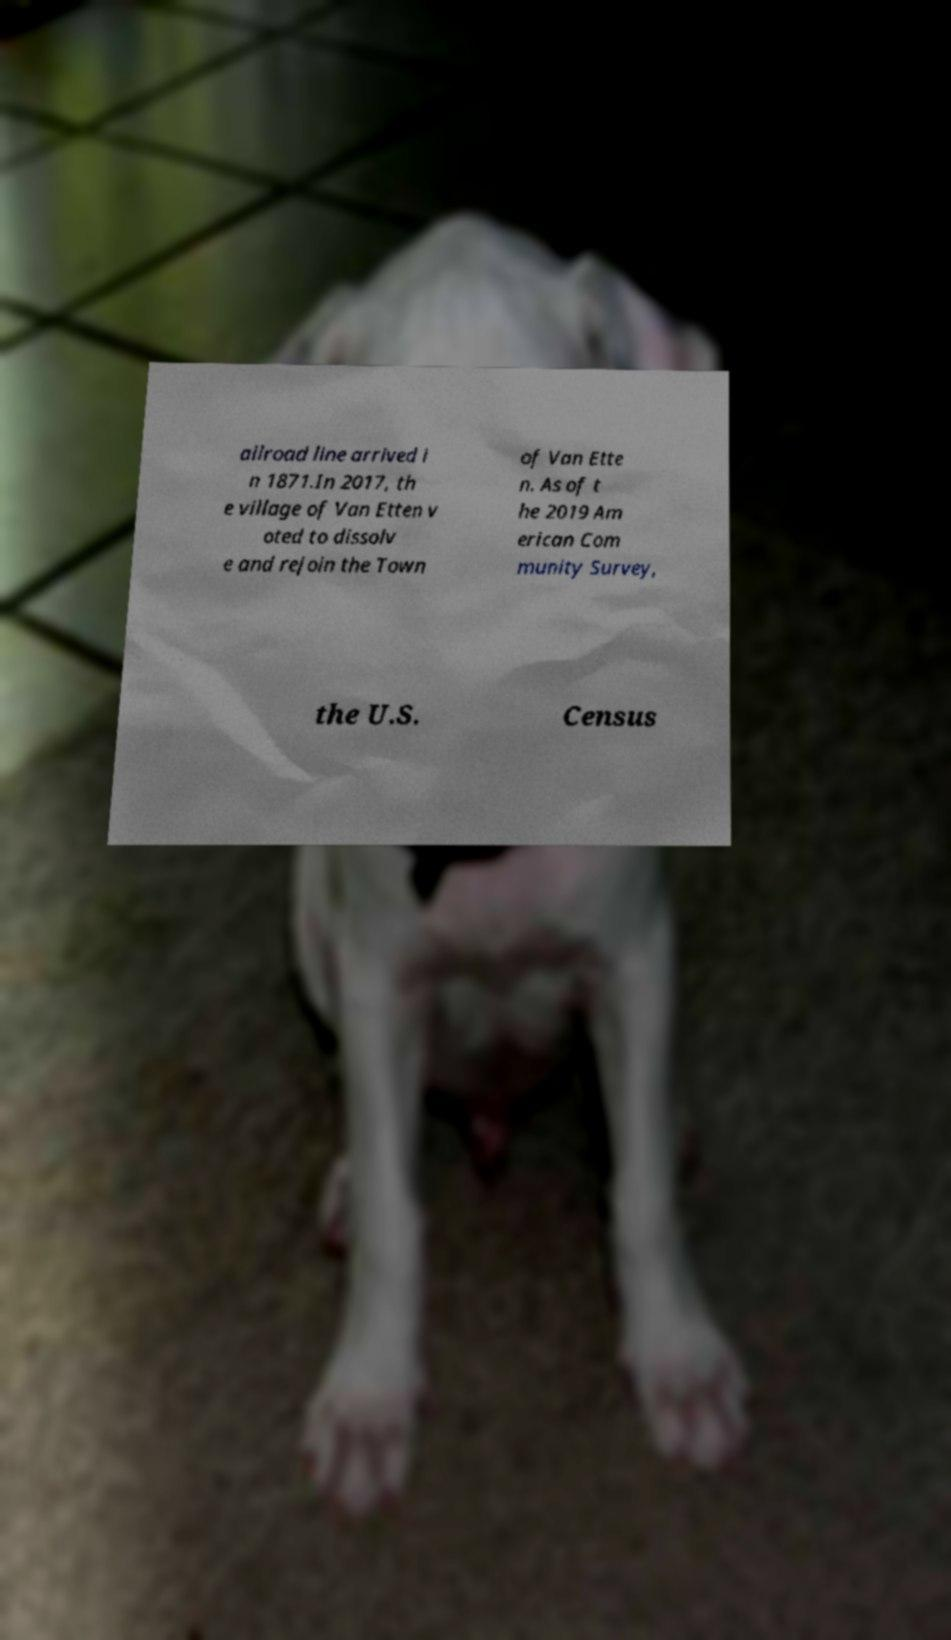Could you assist in decoding the text presented in this image and type it out clearly? ailroad line arrived i n 1871.In 2017, th e village of Van Etten v oted to dissolv e and rejoin the Town of Van Ette n. As of t he 2019 Am erican Com munity Survey, the U.S. Census 